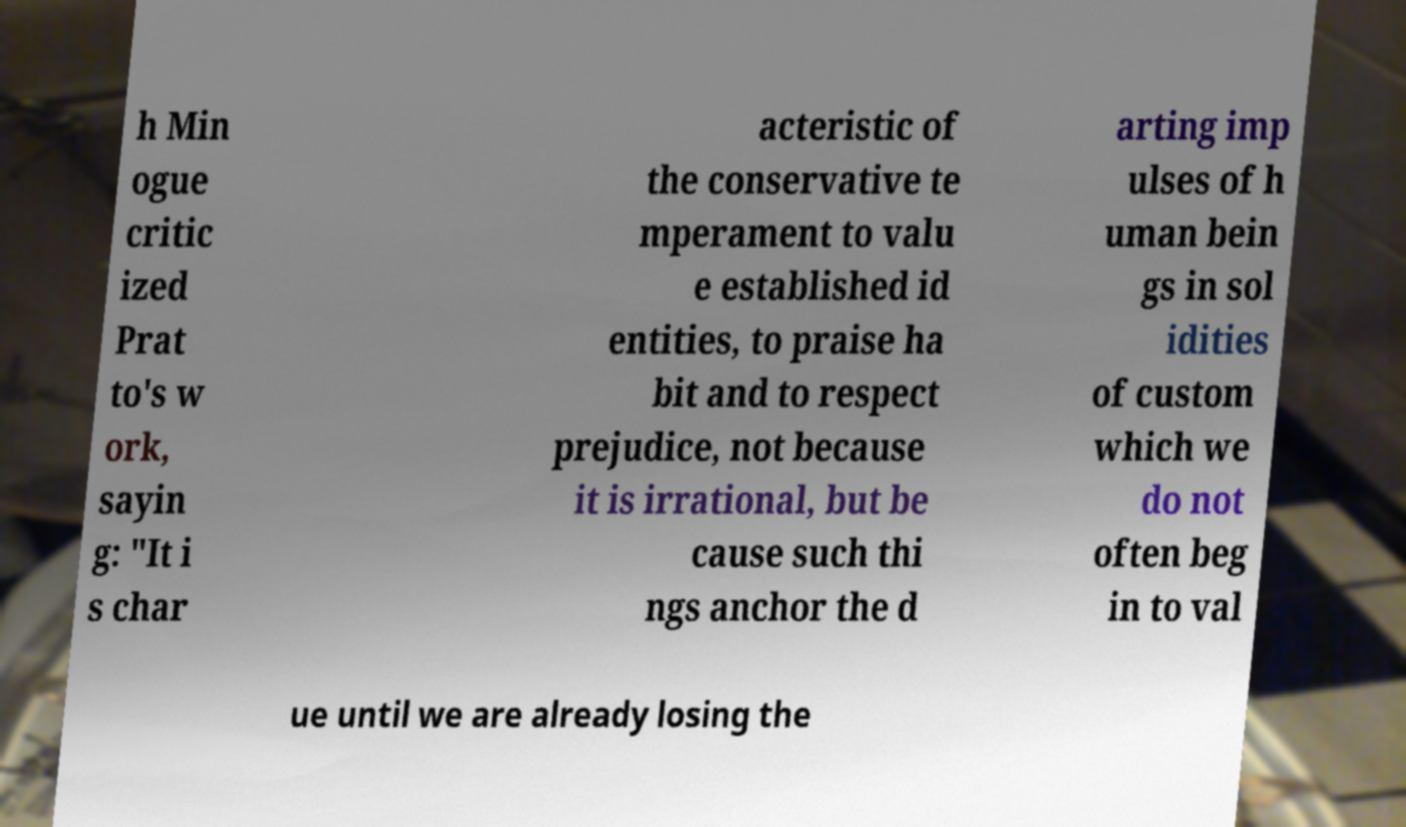Could you assist in decoding the text presented in this image and type it out clearly? h Min ogue critic ized Prat to's w ork, sayin g: "It i s char acteristic of the conservative te mperament to valu e established id entities, to praise ha bit and to respect prejudice, not because it is irrational, but be cause such thi ngs anchor the d arting imp ulses of h uman bein gs in sol idities of custom which we do not often beg in to val ue until we are already losing the 